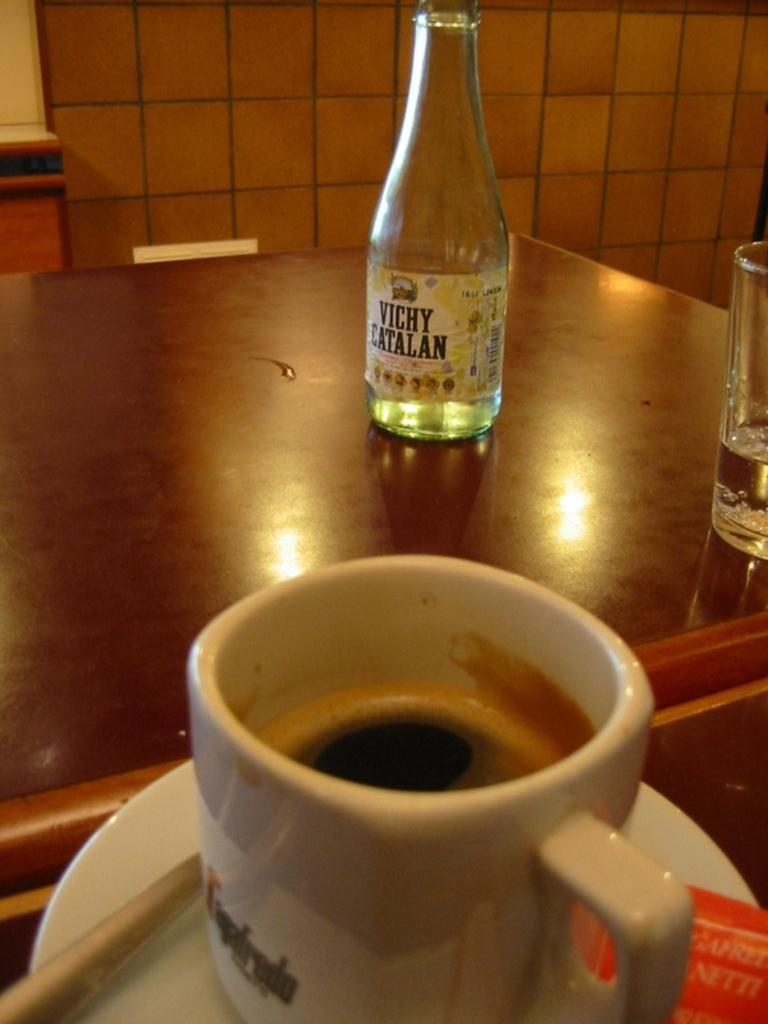<image>
Present a compact description of the photo's key features. A bottle of Vichy Catalan sits on the worktop. 